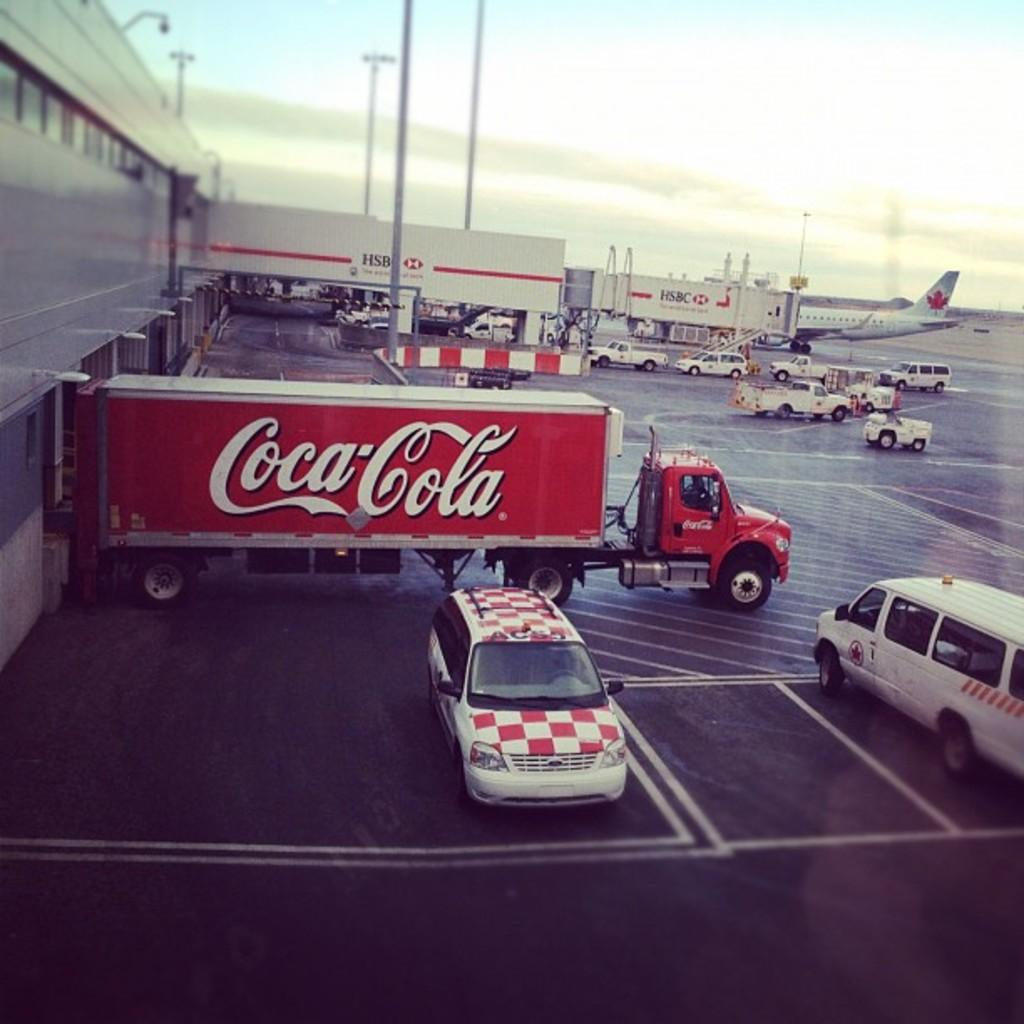<image>
Share a concise interpretation of the image provided. Large red Coca Cola truck docked by a building. 